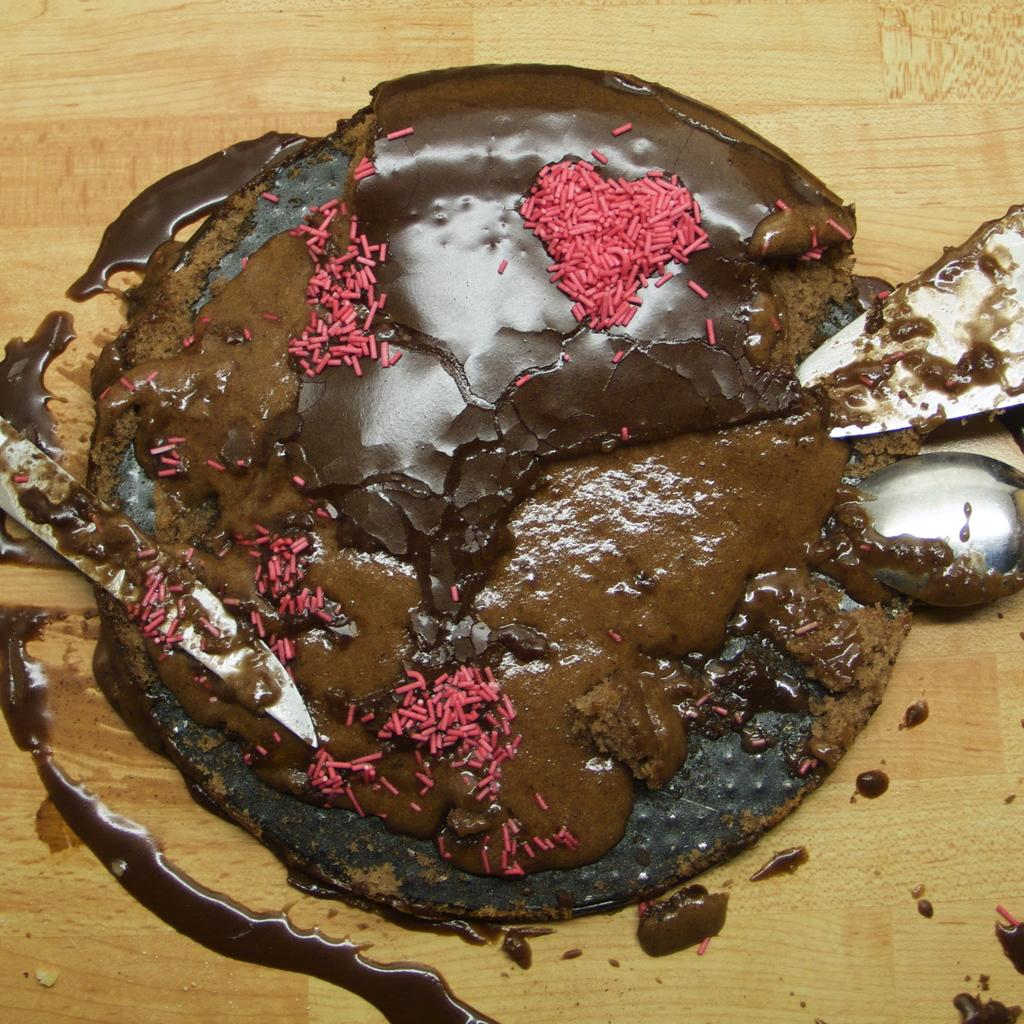What is the main subject in the center of the image? There is a wooden object in the center of the image. What is placed on the wooden object? There are food items and other objects on the wooden object. What color is the stocking hanging from the wooden object in the image? There is no stocking present in the image. What is the price of the wooden object in the image? The price of the wooden object is not mentioned in the image or the provided facts. 